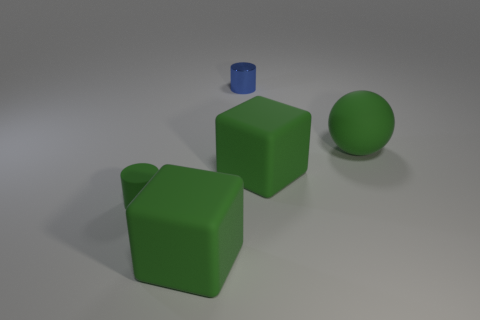There is a green rubber block in front of the block that is behind the tiny rubber cylinder; what size is it?
Offer a very short reply. Large. Are there any small cylinders of the same color as the rubber sphere?
Make the answer very short. Yes. There is a small thing that is in front of the large sphere; is it the same shape as the tiny thing that is behind the small rubber thing?
Offer a terse response. Yes. What is the size of the rubber cylinder that is the same color as the matte ball?
Offer a terse response. Small. What number of other objects are there of the same size as the matte cylinder?
Ensure brevity in your answer.  1. There is a small matte cylinder; is it the same color as the rubber thing that is in front of the tiny green rubber cylinder?
Make the answer very short. Yes. Is the number of tiny green rubber cylinders behind the small green cylinder less than the number of objects that are left of the ball?
Your answer should be compact. Yes. What is the color of the object that is both right of the small green rubber cylinder and on the left side of the blue shiny thing?
Keep it short and to the point. Green. There is a rubber cylinder; is it the same size as the green rubber block that is in front of the green matte cylinder?
Make the answer very short. No. What is the shape of the big green matte thing in front of the green cylinder?
Provide a succinct answer. Cube. 